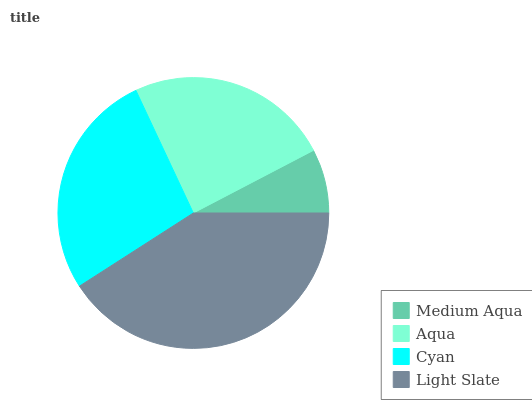Is Medium Aqua the minimum?
Answer yes or no. Yes. Is Light Slate the maximum?
Answer yes or no. Yes. Is Aqua the minimum?
Answer yes or no. No. Is Aqua the maximum?
Answer yes or no. No. Is Aqua greater than Medium Aqua?
Answer yes or no. Yes. Is Medium Aqua less than Aqua?
Answer yes or no. Yes. Is Medium Aqua greater than Aqua?
Answer yes or no. No. Is Aqua less than Medium Aqua?
Answer yes or no. No. Is Cyan the high median?
Answer yes or no. Yes. Is Aqua the low median?
Answer yes or no. Yes. Is Medium Aqua the high median?
Answer yes or no. No. Is Medium Aqua the low median?
Answer yes or no. No. 